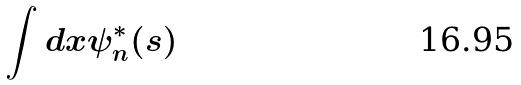Convert formula to latex. <formula><loc_0><loc_0><loc_500><loc_500>\int d x \psi _ { n } ^ { * } ( s )</formula> 